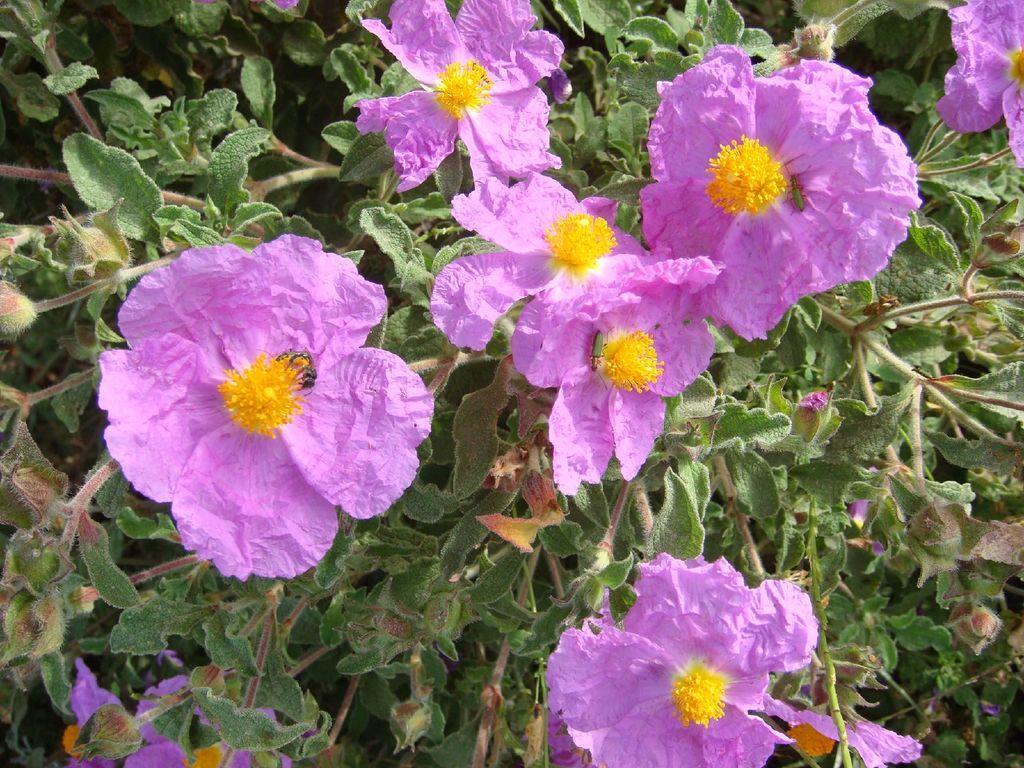Could you give a brief overview of what you see in this image? In the center of the image we can see plants with flowers, which are in pink and yellow color. 